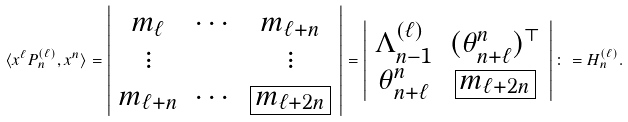Convert formula to latex. <formula><loc_0><loc_0><loc_500><loc_500>\langle x ^ { \ell } P _ { n } ^ { ( \ell ) } , x ^ { n } \rangle = \left | \begin{array} { c c c } m _ { \ell } & \cdots & m _ { \ell + n } \\ \vdots & & \vdots \\ m _ { \ell + n } & \cdots & \boxed { m _ { \ell + 2 n } } \end{array} \right | = \left | \begin{array} { c c } \Lambda ^ { ( \ell ) } _ { n - 1 } & ( \theta _ { n + \ell } ^ { n } ) ^ { \top } \\ \theta _ { n + \ell } ^ { n } & \boxed { m _ { \ell + 2 n } } \end{array} \right | \colon = H _ { n } ^ { ( \ell ) } .</formula> 